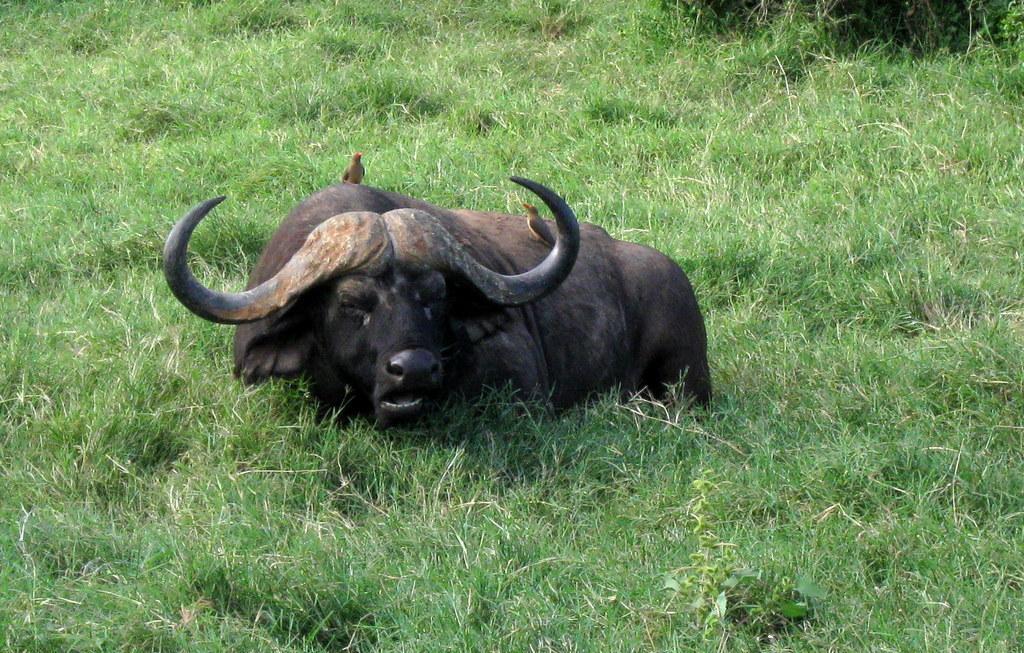Describe this image in one or two sentences. In the foreground of this image, there is a buffalo sitting on the grass and there are two birds on it. 